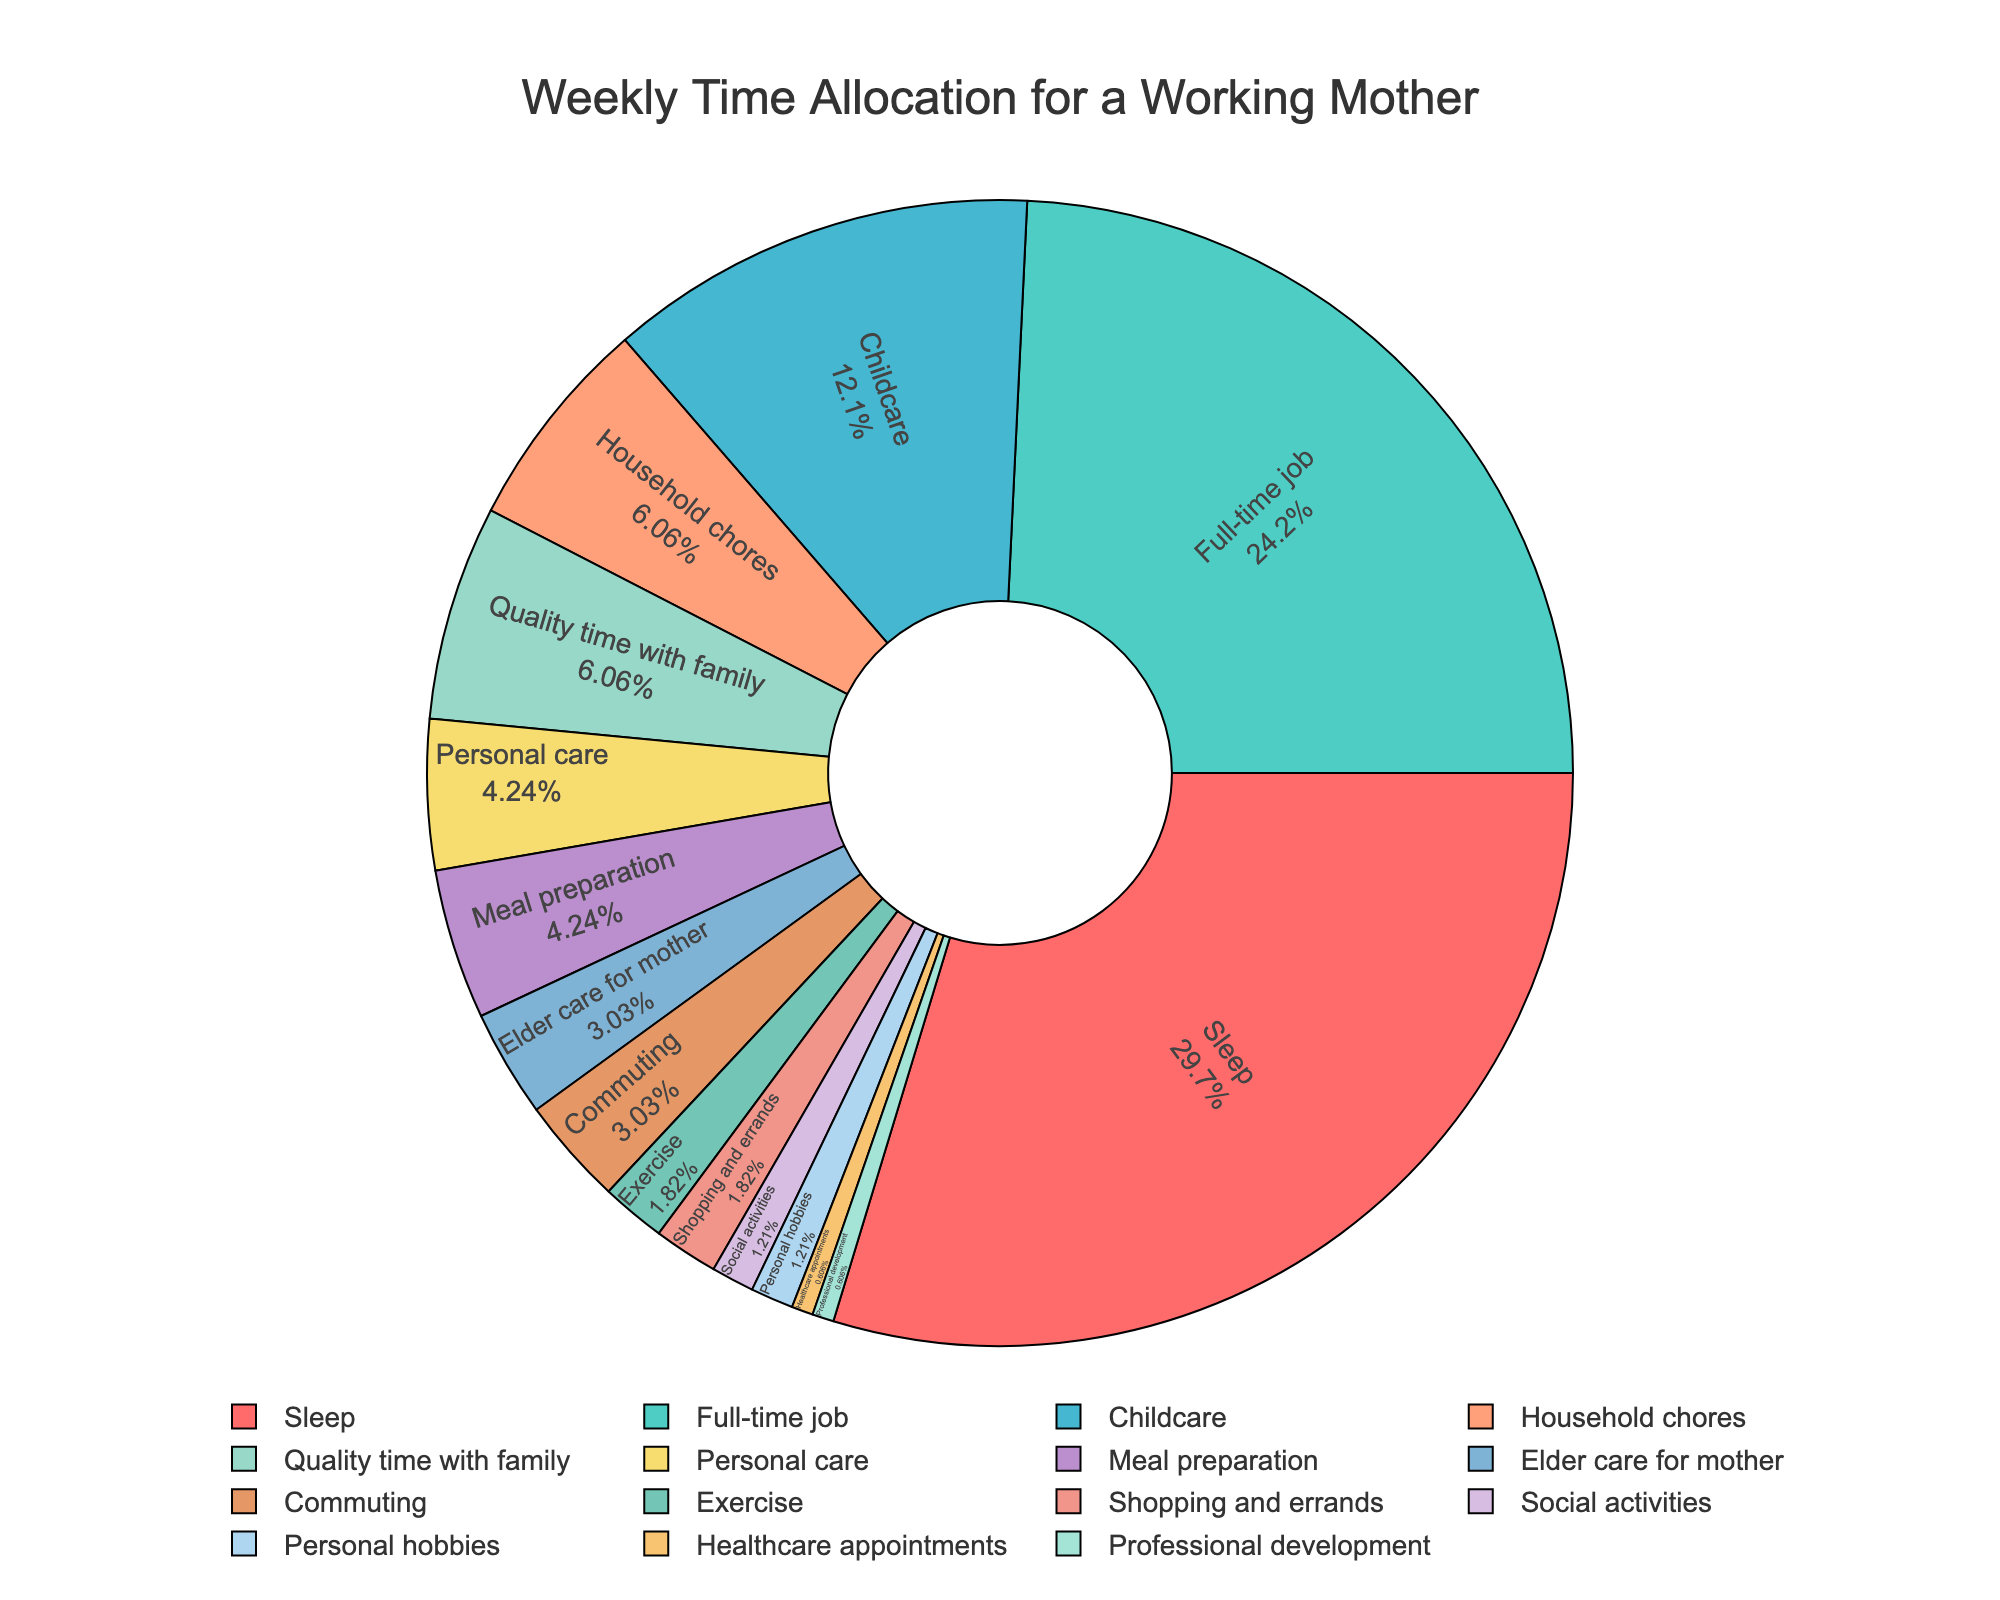Which activity takes up the largest portion of time per week? By looking at the pie chart, the activity segment with the largest slice represents the most time-consuming activity, which is labeled "Full-time job."
Answer: Full-time job How many hours per week are spent on household chores and elder care combined? Add the hours for "Household chores" (10 hours) and "Elder care for mother" (5 hours) to get the total combined time. 10 + 5 = 15
Answer: 15 Is more time spent on commuting or on exercise? By visually comparing the slices for "Commuting" and "Exercise," the "Commuting" segment appears larger than the "Exercise" segment. The actual hours are 5 for commuting and 3 for exercise.
Answer: Commuting Which activities take up exactly 1 hour per week? Look for the smallest segments labeled with values of 1 hour. These segments are "Healthcare appointments" and "Professional development."
Answer: Healthcare appointments, Professional development What percentage of time is spent on meal preparation relative to the total weekly hours? First, calculate the total weekly hours by summing all hours (160). Then, find the percentage of time for "Meal preparation" (7 hours) by (7/160) * 100%.
Answer: 4.38% Which non-personal care activities take the least amount of time each week? Find the smallest segments excluding "Personal care," "Personal hobbies," "Healthcare appointments," and "Professional development." The smallest segments among non-personal care activities are "Social activities" and "Shopping and errands" at 2 and 3 hours, respectively.
Answer: Social activities, Shopping and errands How does the time spent on personal hobbies compare to time spent on social activities? Both "Personal hobbies" and "Social activities" have segments. By visually comparing their sizes, both are nearly equal. Both activities take 2 hours each.
Answer: Equal If you were to increase exercise time by 2 hours weekly, how would this impact the total weekly hours? Increasing "Exercise" time from 3 to 5 hours means adding 2 hours to the current total of 160 hours. The new total would be 160 + 2 = 162 hours.
Answer: 162 What is the ratio of hours spent on quality time with family to hours spent on professional development? The hours for "Quality time with family" are 10 and for "Professional development" are 1. The ratio is 10:1.
Answer: 10:1 